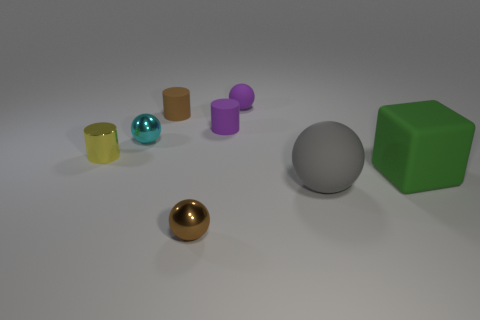Add 1 red cylinders. How many objects exist? 9 Subtract 1 spheres. How many spheres are left? 3 Subtract all yellow cylinders. How many cyan balls are left? 1 Subtract all big green matte cubes. Subtract all gray things. How many objects are left? 6 Add 3 large cubes. How many large cubes are left? 4 Add 6 big gray spheres. How many big gray spheres exist? 7 Subtract all yellow cylinders. How many cylinders are left? 2 Subtract all cyan metal spheres. How many spheres are left? 3 Subtract 0 blue cubes. How many objects are left? 8 Subtract all cylinders. How many objects are left? 5 